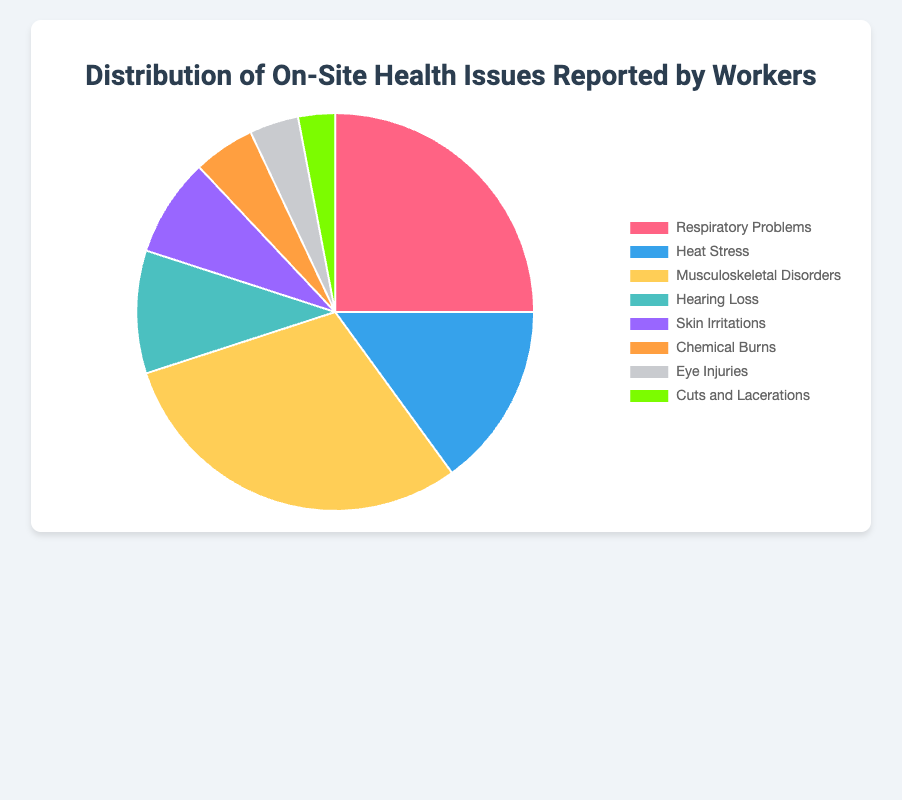What is the most commonly reported health issue? Identify the issue with the highest percentage. Musculoskeletal Disorders is at 30%, which is the highest.
Answer: Musculoskeletal Disorders How does the percentage of heat stress compare to that of respiratory problems? Compare the percentages: Heat Stress is 15% and Respiratory Problems are 25%.
Answer: Heat Stress is less than Respiratory Problems What is the combined percentage of eye injuries and cuts and lacerations? Add the percentages: Eye Injuries are 4% and Cuts and Lacerations are 3%. The combined percentage is 4 + 3 = 7%.
Answer: 7% Which health issue has the smallest percentage, and what is that percentage? Identify the issue with the smallest slice. Cuts and Lacerations is at 3%, the smallest.
Answer: Cuts and Lacerations, 3% How much more common are musculoskeletal disorders compared to hearing loss? Subtract the percentage of Hearing Loss from Musculoskeletal Disorders: 30% - 10% = 20%.
Answer: 20% What is the total percentage for respiratory problems, skin irritations, and chemical burns combined? Add up the percentages: Respiratory Problems (25%), Skin Irritations (8%), Chemical Burns (5%). Total is 25 + 8 + 5 = 38%.
Answer: 38% Which issue has a greater percentage, chemical burns or eye injuries? Compare the percentages: Chemical Burns (5%) and Eye Injuries (4%).
Answer: Chemical Burns If you combine respiratory problems and eye injuries, what is the total percentage? Add the percentages: Respiratory Problems are 25% and Eye Injuries are 4%. Total is 25 + 4 = 29%.
Answer: 29% How does the percentage of skin irritations compare to chemical burns? Compare the percentages: Skin Irritations are 8% and Chemical Burns are 5%.
Answer: Skin Irritations are more than Chemical Burns What percentage of reported health issues are related to physical trauma (cuts and lacerations and eye injuries)? Add the percentages: Cuts and Lacerations (3%) and Eye Injuries (4%). Total is 3 + 4 = 7%.
Answer: 7% 